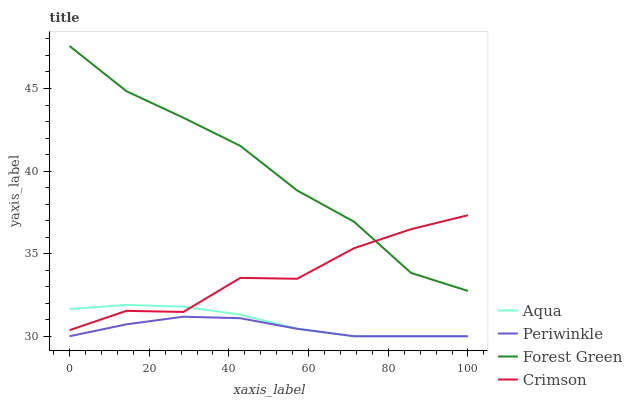Does Forest Green have the minimum area under the curve?
Answer yes or no. No. Does Periwinkle have the maximum area under the curve?
Answer yes or no. No. Is Periwinkle the smoothest?
Answer yes or no. No. Is Periwinkle the roughest?
Answer yes or no. No. Does Forest Green have the lowest value?
Answer yes or no. No. Does Periwinkle have the highest value?
Answer yes or no. No. Is Aqua less than Forest Green?
Answer yes or no. Yes. Is Crimson greater than Periwinkle?
Answer yes or no. Yes. Does Aqua intersect Forest Green?
Answer yes or no. No. 